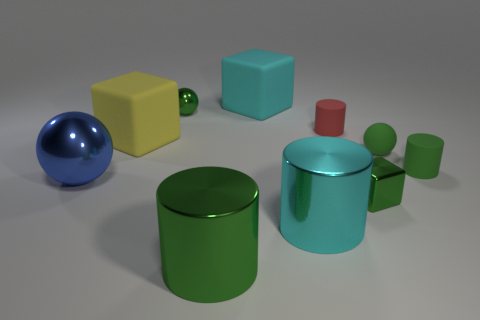What can you infer about the material of the objects based on their appearance? Based on their appearance, the objects seem to be made of a plastic or smooth ceramic material. This inference comes from the way light is reflected and absorbed by the objects' surfaces, as well as the slight highlights and shadows that define their shapes. 